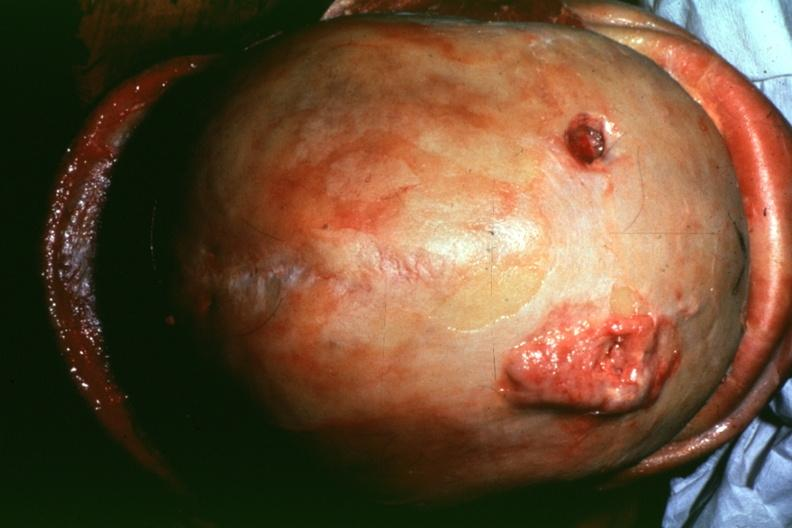does this image show dr garcia tumors b4?
Answer the question using a single word or phrase. Yes 